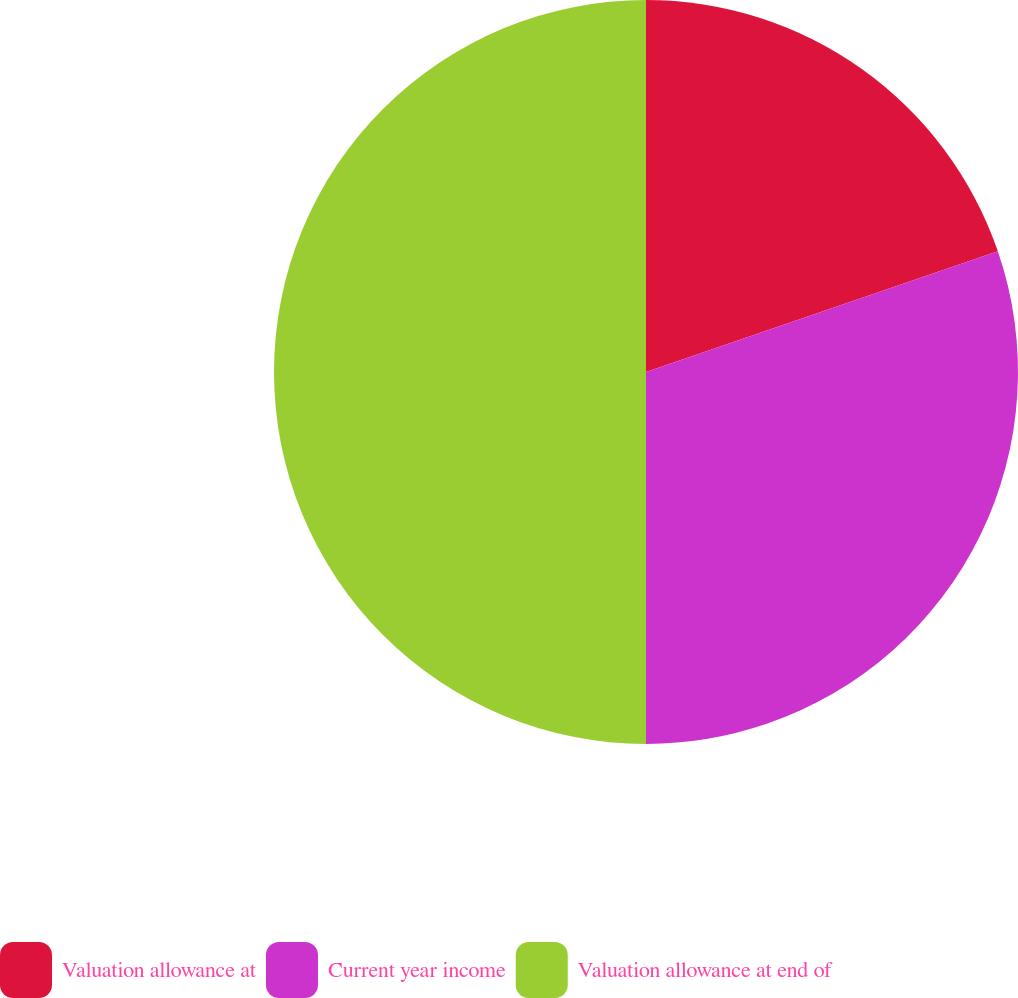Convert chart to OTSL. <chart><loc_0><loc_0><loc_500><loc_500><pie_chart><fcel>Valuation allowance at<fcel>Current year income<fcel>Valuation allowance at end of<nl><fcel>19.74%<fcel>30.26%<fcel>50.0%<nl></chart> 